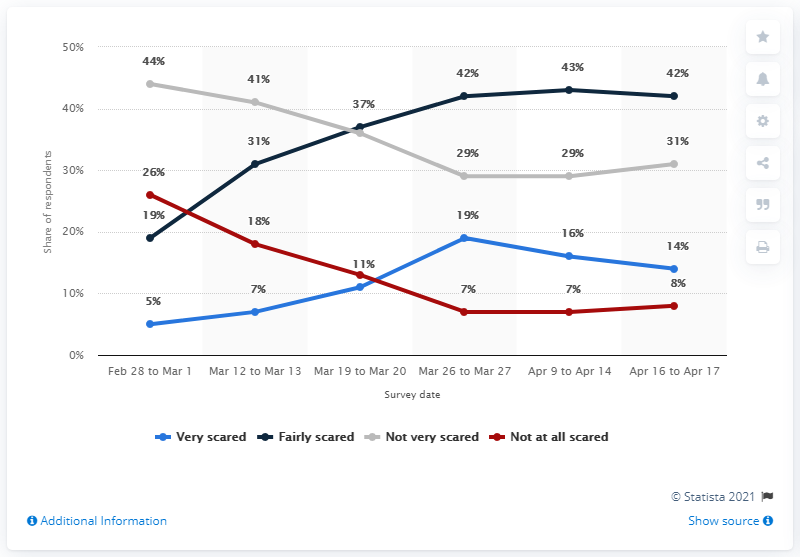Point out several critical features in this image. There were 214 people who were fairly scared. According to a survey conducted in Britain, a significant percentage of adults were scared of contracting the coronavirus in January 2021. The grey line in the chart suggests that the subject is not afraid. A majority of Brits are not scared of contracting COVID-19, with 26% stating that they are not concerned at all. 